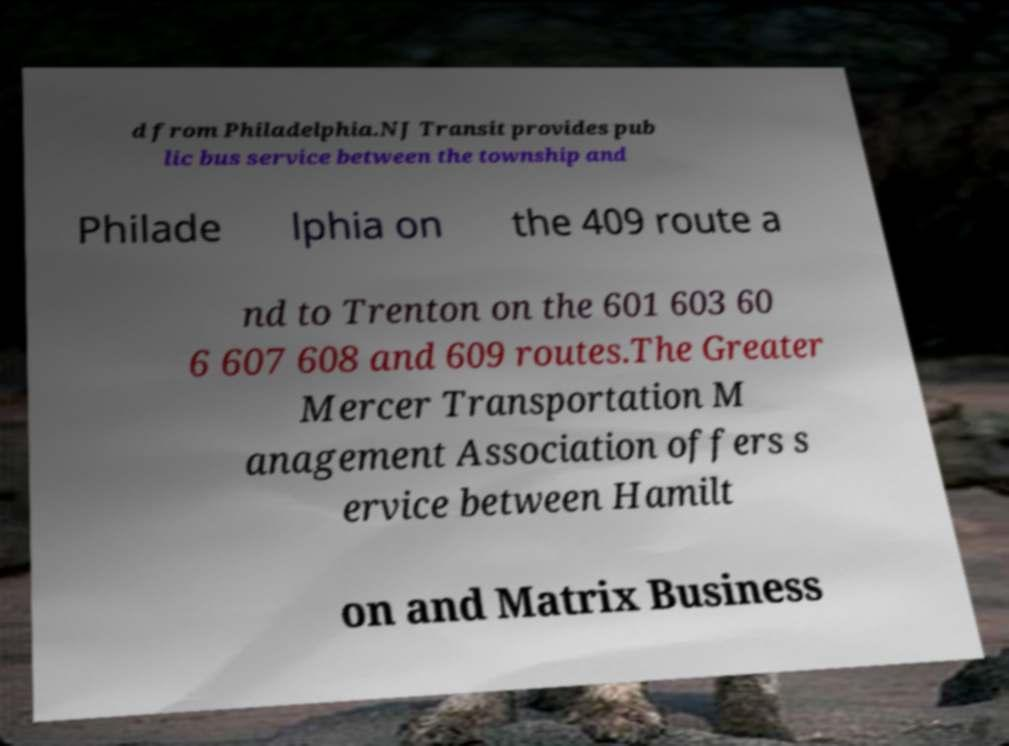Can you read and provide the text displayed in the image?This photo seems to have some interesting text. Can you extract and type it out for me? d from Philadelphia.NJ Transit provides pub lic bus service between the township and Philade lphia on the 409 route a nd to Trenton on the 601 603 60 6 607 608 and 609 routes.The Greater Mercer Transportation M anagement Association offers s ervice between Hamilt on and Matrix Business 